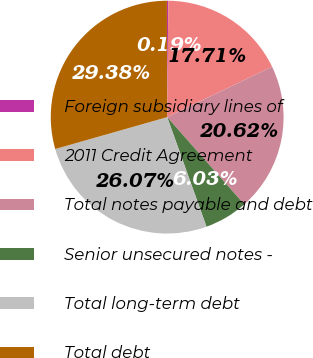Convert chart. <chart><loc_0><loc_0><loc_500><loc_500><pie_chart><fcel>Foreign subsidiary lines of<fcel>2011 Credit Agreement<fcel>Total notes payable and debt<fcel>Senior unsecured notes -<fcel>Total long-term debt<fcel>Total debt<nl><fcel>0.19%<fcel>17.71%<fcel>20.62%<fcel>6.03%<fcel>26.07%<fcel>29.38%<nl></chart> 